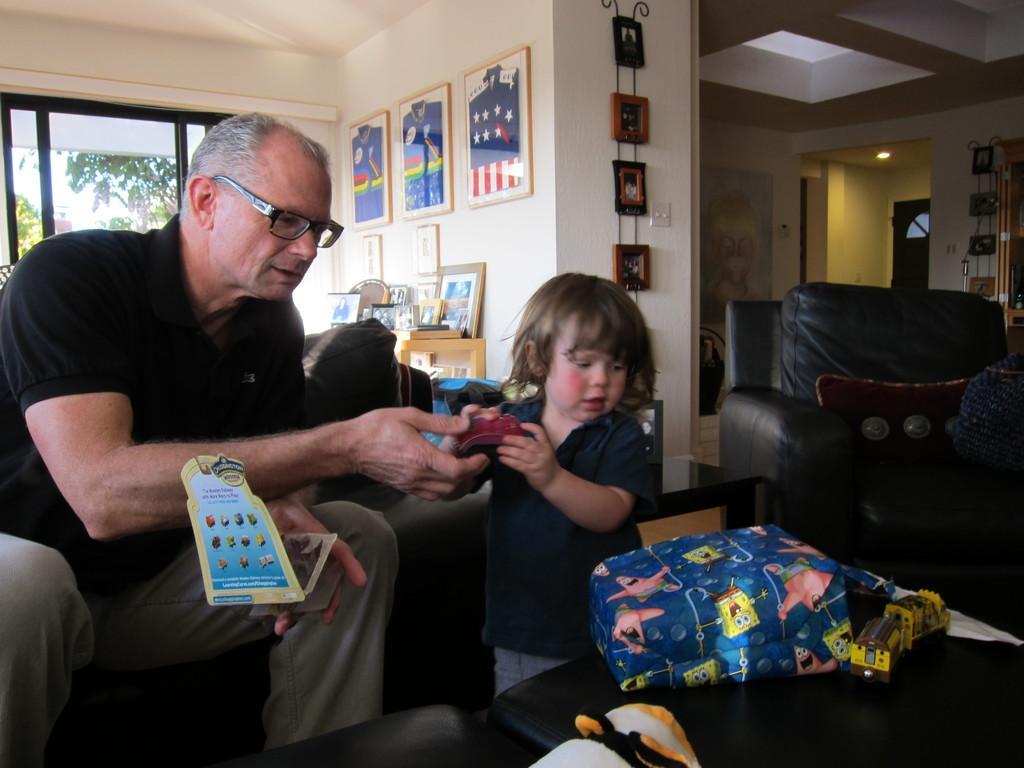Can you describe this image briefly? In this image the man is sitting on the chair. The child is standing. In front there is a bag and a toy. At the back side on table there are frames. 